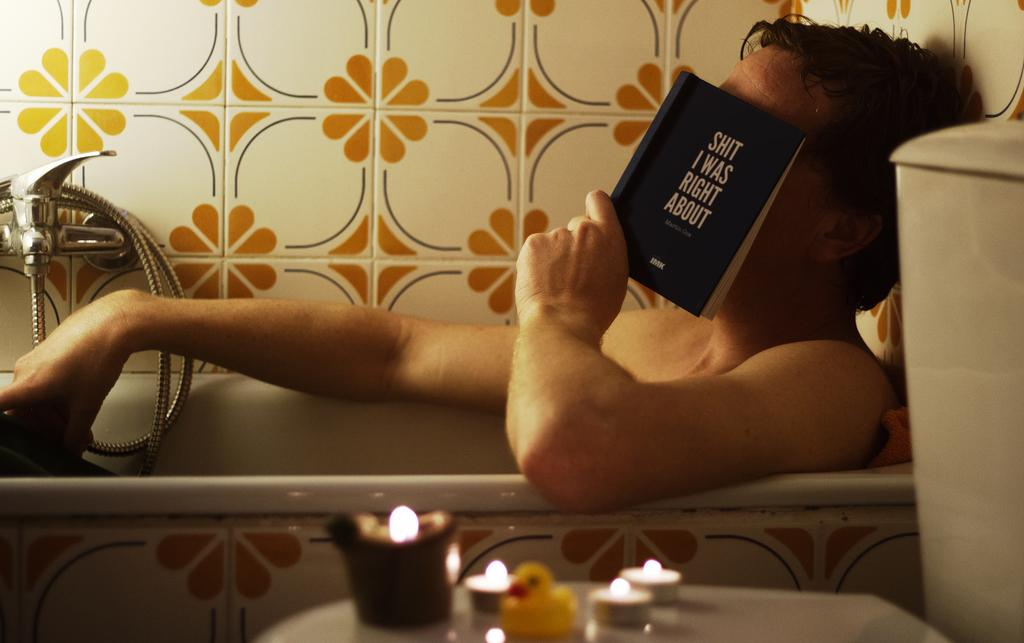<image>
Relay a brief, clear account of the picture shown. A man in a bathtub is holding a book to his face that says I Was Right About. 